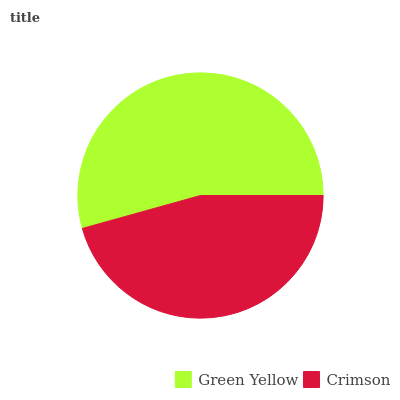Is Crimson the minimum?
Answer yes or no. Yes. Is Green Yellow the maximum?
Answer yes or no. Yes. Is Crimson the maximum?
Answer yes or no. No. Is Green Yellow greater than Crimson?
Answer yes or no. Yes. Is Crimson less than Green Yellow?
Answer yes or no. Yes. Is Crimson greater than Green Yellow?
Answer yes or no. No. Is Green Yellow less than Crimson?
Answer yes or no. No. Is Green Yellow the high median?
Answer yes or no. Yes. Is Crimson the low median?
Answer yes or no. Yes. Is Crimson the high median?
Answer yes or no. No. Is Green Yellow the low median?
Answer yes or no. No. 